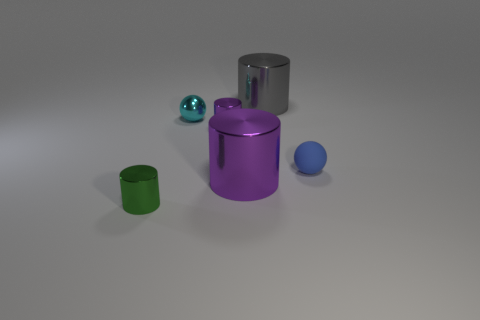Is there any other thing that is the same material as the small blue object?
Make the answer very short. No. Is the color of the tiny rubber ball the same as the large thing behind the cyan metal object?
Ensure brevity in your answer.  No. There is a tiny metal cylinder that is right of the metal thing that is to the left of the tiny metal sphere; are there any small purple metal cylinders behind it?
Your response must be concise. No. What shape is the large purple thing that is made of the same material as the green cylinder?
Ensure brevity in your answer.  Cylinder. What is the shape of the tiny green object?
Give a very brief answer. Cylinder. There is a purple thing behind the small blue matte sphere; is its shape the same as the tiny matte thing?
Your answer should be very brief. No. Are there more shiny cylinders that are to the left of the large purple metallic cylinder than balls right of the large gray thing?
Offer a terse response. Yes. What number of other things are there of the same size as the blue rubber thing?
Give a very brief answer. 3. There is a cyan object; does it have the same shape as the thing that is on the right side of the big gray cylinder?
Your answer should be compact. Yes. What number of metallic things are either blue things or tiny green things?
Provide a succinct answer. 1. 